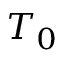<formula> <loc_0><loc_0><loc_500><loc_500>T _ { 0 }</formula> 